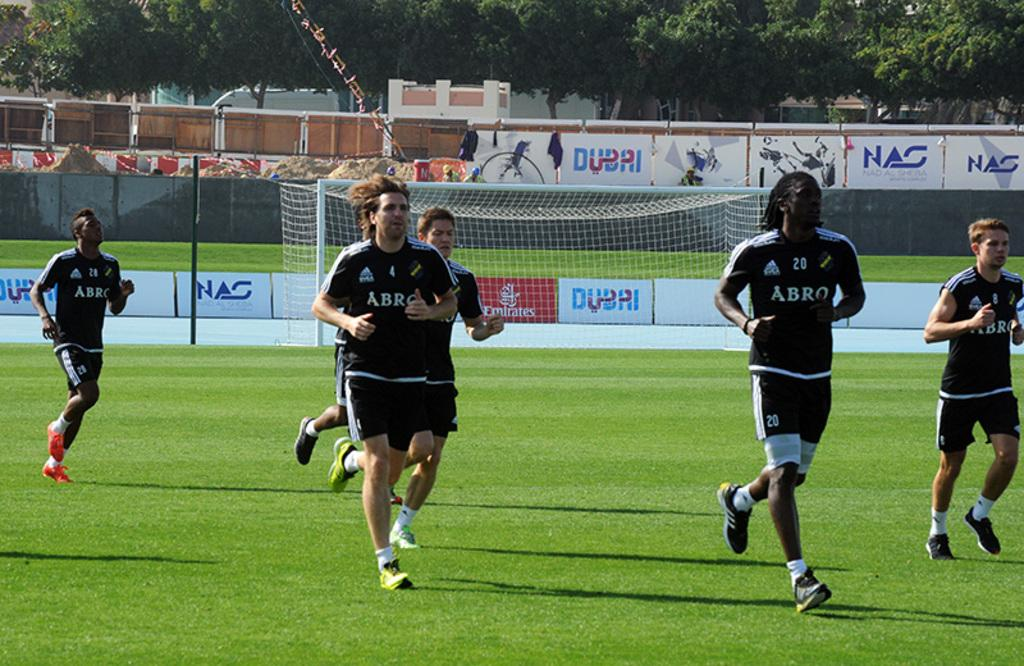Provide a one-sentence caption for the provided image. Several soccer players jog across the field, wearing jerseys that say Arbo. 